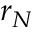Convert formula to latex. <formula><loc_0><loc_0><loc_500><loc_500>r _ { N }</formula> 